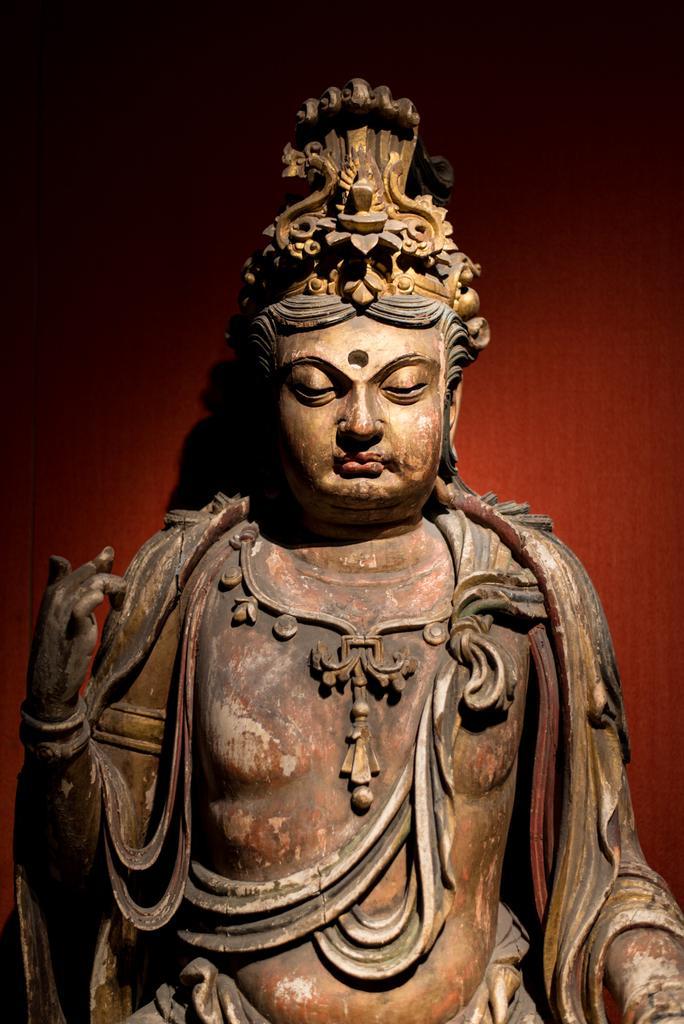In one or two sentences, can you explain what this image depicts? In this image we can see a sculpture and in the background the image is in red color. 